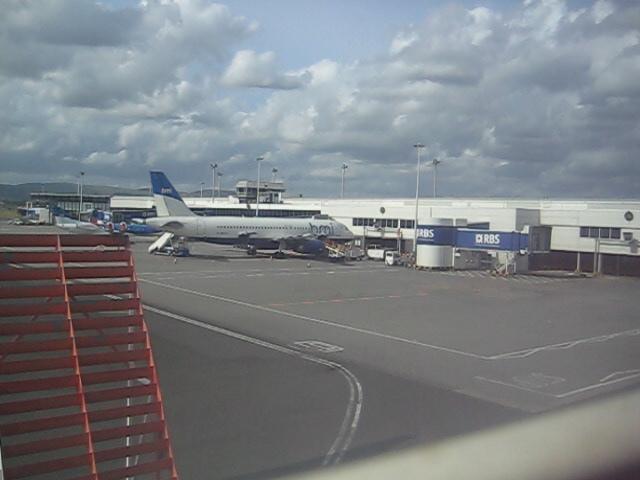How many planes are here?
Give a very brief answer. 1. 